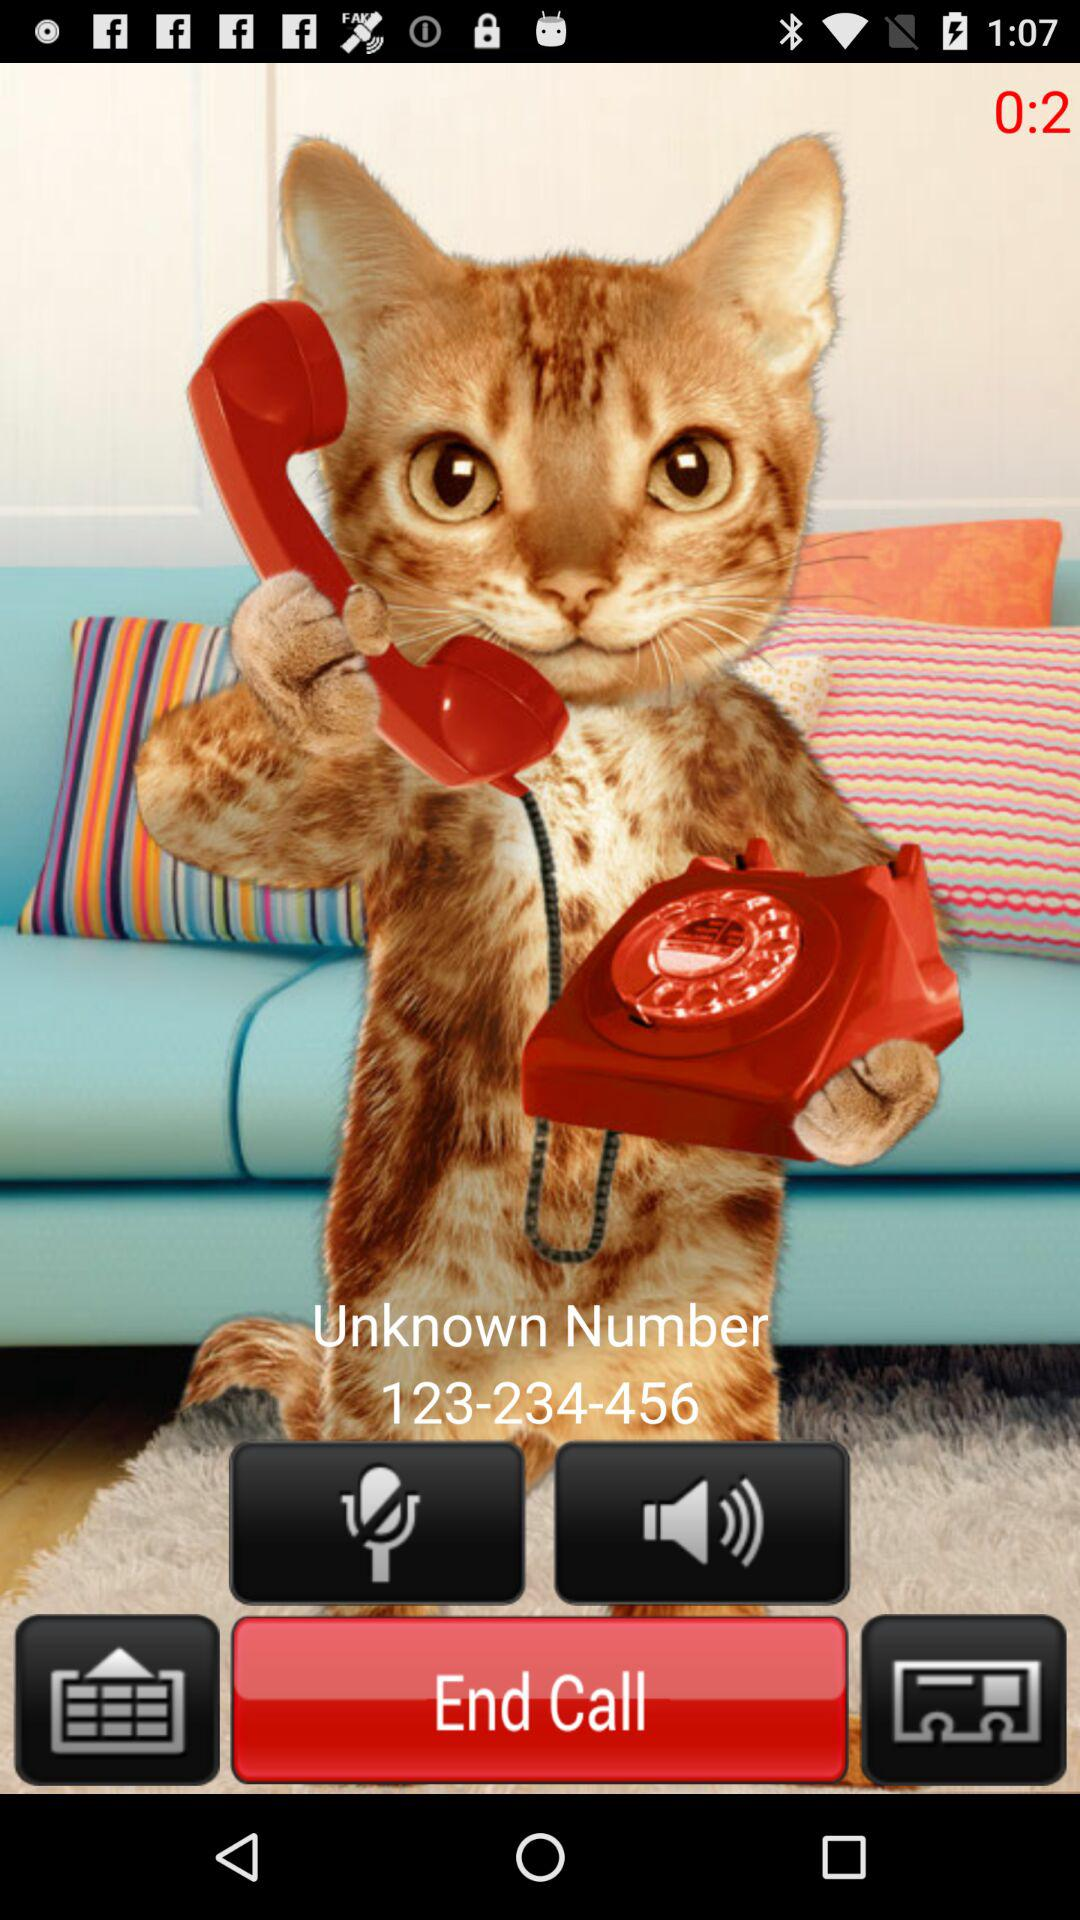How many seconds are left in the call?
Answer the question using a single word or phrase. 2 